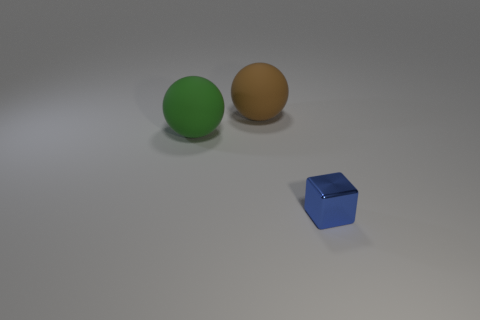What time of day do you think it is in this image? Given the controlled lighting and lack of environmental context, it's not possible to determine the time of day from this image; it seems to be taken in an indoor setting with artificial lighting. 